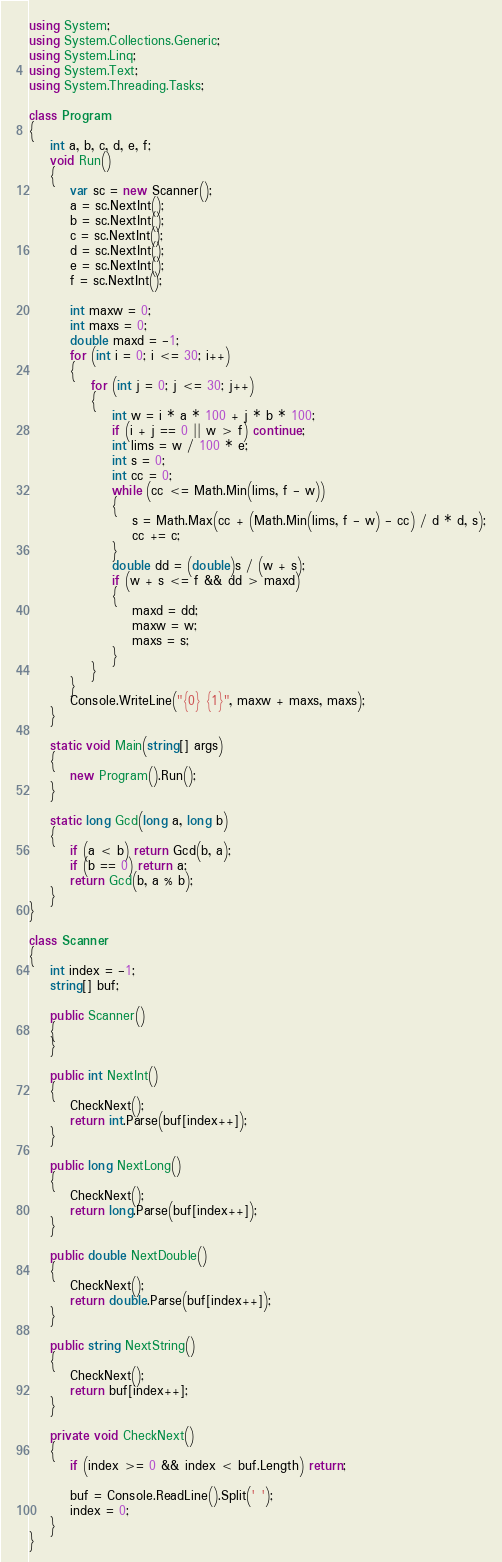Convert code to text. <code><loc_0><loc_0><loc_500><loc_500><_C#_>using System;
using System.Collections.Generic;
using System.Linq;
using System.Text;
using System.Threading.Tasks;

class Program
{
    int a, b, c, d, e, f;
    void Run()
    {
        var sc = new Scanner();
        a = sc.NextInt();
        b = sc.NextInt();
        c = sc.NextInt();
        d = sc.NextInt();
        e = sc.NextInt();
        f = sc.NextInt();

        int maxw = 0;
        int maxs = 0;
        double maxd = -1;
        for (int i = 0; i <= 30; i++)
        {
            for (int j = 0; j <= 30; j++)
            {
                int w = i * a * 100 + j * b * 100;
                if (i + j == 0 || w > f) continue;
                int lims = w / 100 * e;
                int s = 0;
                int cc = 0;
                while (cc <= Math.Min(lims, f - w))
                {
                    s = Math.Max(cc + (Math.Min(lims, f - w) - cc) / d * d, s);
                    cc += c;
                }
                double dd = (double)s / (w + s);
                if (w + s <= f && dd > maxd)
                {
                    maxd = dd;
                    maxw = w;
                    maxs = s;
                }
            }
        }
        Console.WriteLine("{0} {1}", maxw + maxs, maxs);
    }

    static void Main(string[] args)
    {
        new Program().Run();
    }

    static long Gcd(long a, long b)
    {
        if (a < b) return Gcd(b, a);
        if (b == 0) return a;
        return Gcd(b, a % b);
    }
}

class Scanner
{
    int index = -1;
    string[] buf;

    public Scanner()
    {
    }

    public int NextInt()
    {
        CheckNext();
        return int.Parse(buf[index++]);
    }

    public long NextLong()
    {
        CheckNext();
        return long.Parse(buf[index++]);
    }

    public double NextDouble()
    {
        CheckNext();
        return double.Parse(buf[index++]);
    }

    public string NextString()
    {
        CheckNext();
        return buf[index++];
    }

    private void CheckNext()
    {
        if (index >= 0 && index < buf.Length) return;

        buf = Console.ReadLine().Split(' ');
        index = 0;
    }
}
</code> 